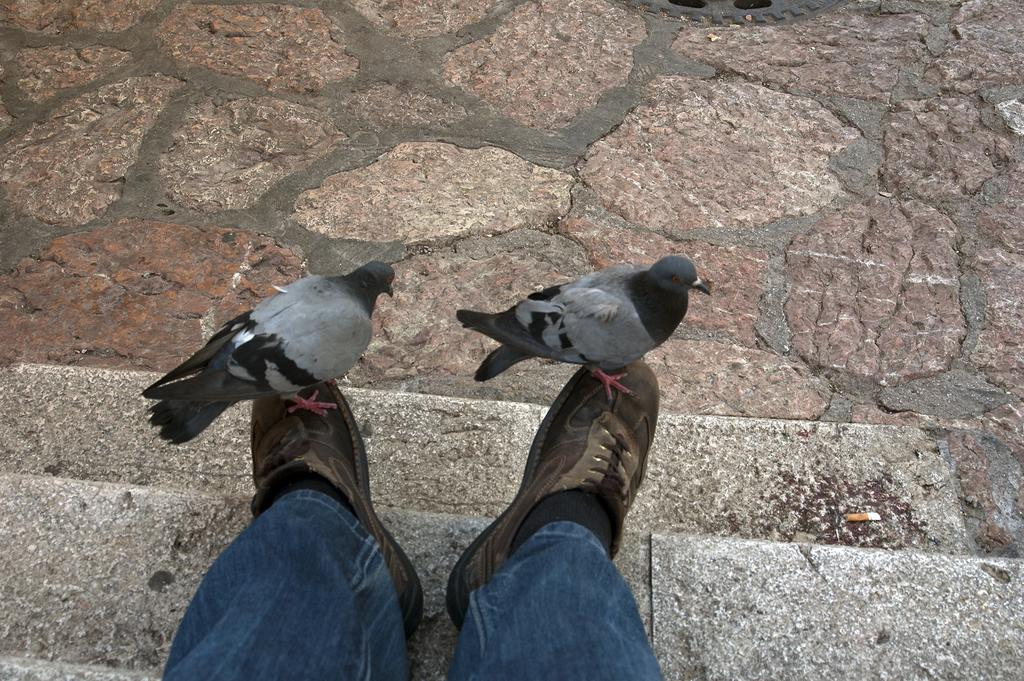What is the main subject of the image? The main subject of the image is a person's legs with shoes. Where are the legs located in the image? The legs are on the steps. What other animals are present in the image? There are two birds standing on the shoes. What is visible behind the birds in the image? There is a floor visible behind the birds. What type of volleyball game is being played in the image? There is no volleyball game present in the image. How many spiders are crawling on the person's legs in the image? There are no spiders present in the image; only the two birds are standing on the shoes. 